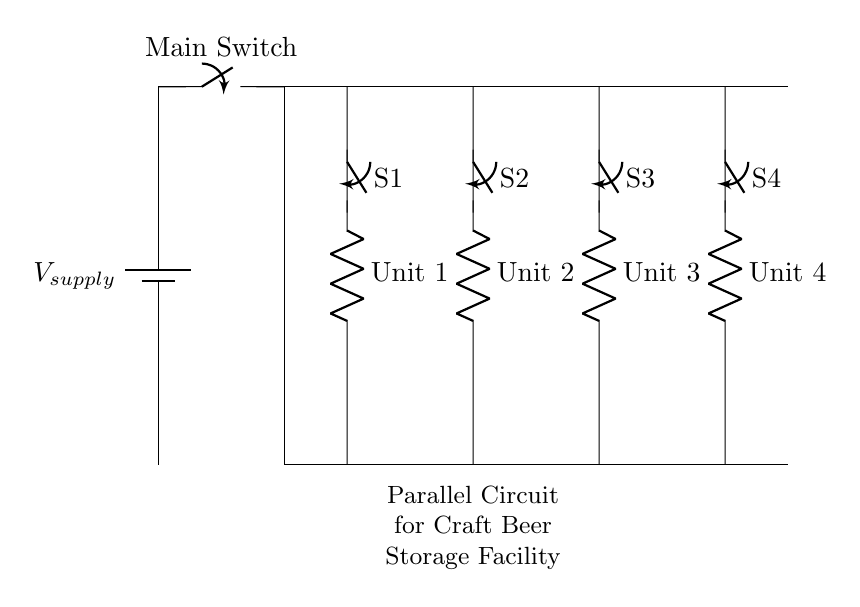What type of circuit is shown? The circuit is a parallel circuit, which is indicated by multiple components connected across common voltage lines without being in series.
Answer: Parallel How many refrigeration units are controlled? There are four refrigeration units, as labeled Unit 1, Unit 2, Unit 3, and Unit 4 in the diagram.
Answer: Four What is the purpose of the main switch? The main switch controls the entire circuit by allowing or interrupting the flow of current from the power supply to all refrigeration units simultaneously.
Answer: Control What do the individual switches control? Each individual switch controls the power to its corresponding refrigeration unit, enabling or disabling each unit independently.
Answer: Independently What happens when one refrigeration unit fails? If one refrigeration unit fails, the others will continue to operate normally since they are connected in parallel and are not dependent on one another for the circuit's functionality.
Answer: Remains operational What maintains the voltage across each refrigeration unit? In a parallel circuit, the voltage across each component is the same as the supply voltage, ensuring that each refrigeration unit receives full voltage regardless of the state of the others.
Answer: Supply voltage What does the circuit diagram indicate about energy supply? It indicates that the energy supply is consistent since all units can operate independently without affecting the overall power supplied to the facility.
Answer: Consistent energy supply 